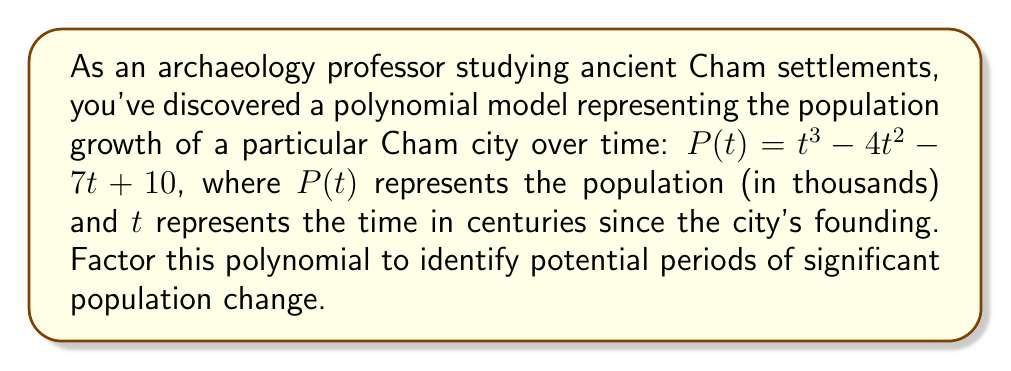Give your solution to this math problem. To factor this cubic polynomial, we'll follow these steps:

1) First, let's check if there are any rational roots using the rational root theorem. The possible rational roots are the factors of the constant term: $\pm1, \pm2, \pm5, \pm10$.

2) Testing these values, we find that $P(1) = 0$. So $(t-1)$ is a factor.

3) We can use polynomial long division to divide $P(t)$ by $(t-1)$:

   $t^3 - 4t^2 - 7t + 10 = (t-1)(t^2 - 3t - 10)$

4) Now we need to factor the quadratic $t^2 - 3t - 10$. We can do this by finding two numbers that multiply to give -10 and add to give -3. These numbers are -5 and 2.

5) Therefore, $t^2 - 3t - 10 = (t-5)(t+2)$

6) Combining all factors, we get:

   $P(t) = t^3 - 4t^2 - 7t + 10 = (t-1)(t-5)(t+2)$

This factorization reveals three significant time points in the city's history:
- When $t=1$ (100 years after founding)
- When $t=5$ (500 years after founding)
- When $t=-2$ (200 years before founding, which might represent a theoretical point or initial settlement)

These points could indicate periods of significant population change or important historical events in the Cham city's development.
Answer: $P(t) = (t-1)(t-5)(t+2)$ 